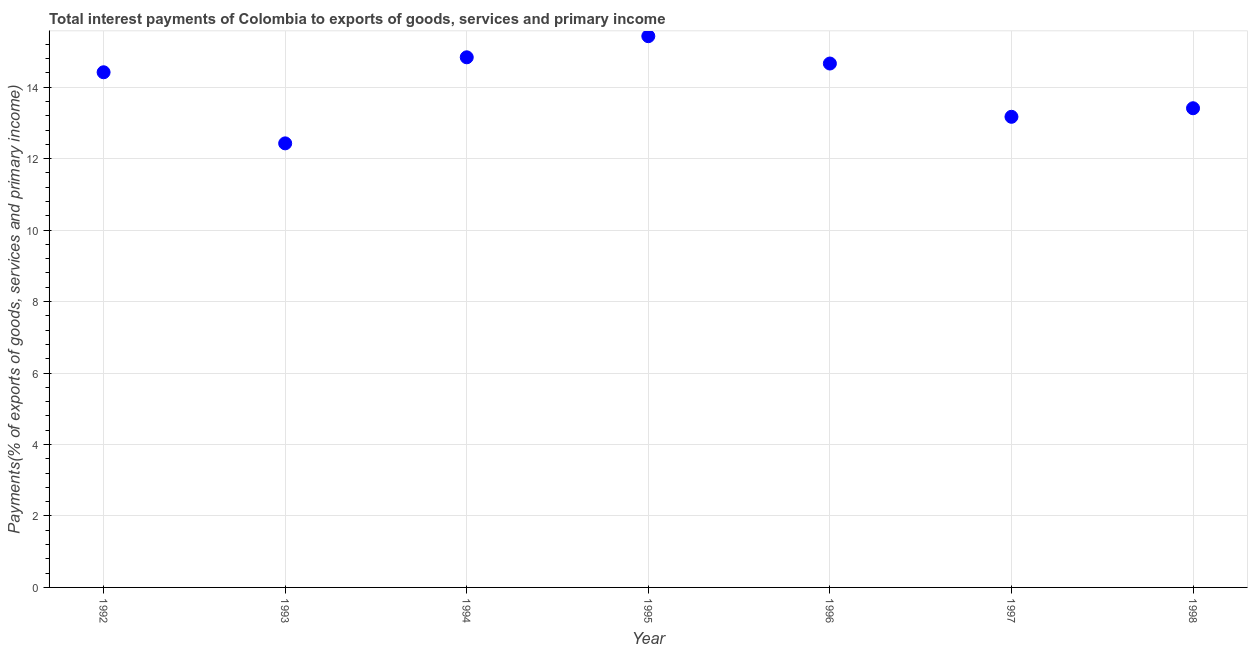What is the total interest payments on external debt in 1992?
Your answer should be very brief. 14.42. Across all years, what is the maximum total interest payments on external debt?
Provide a succinct answer. 15.43. Across all years, what is the minimum total interest payments on external debt?
Keep it short and to the point. 12.43. In which year was the total interest payments on external debt maximum?
Offer a very short reply. 1995. In which year was the total interest payments on external debt minimum?
Your response must be concise. 1993. What is the sum of the total interest payments on external debt?
Your answer should be very brief. 98.34. What is the difference between the total interest payments on external debt in 1996 and 1998?
Keep it short and to the point. 1.25. What is the average total interest payments on external debt per year?
Provide a short and direct response. 14.05. What is the median total interest payments on external debt?
Provide a short and direct response. 14.42. In how many years, is the total interest payments on external debt greater than 11.6 %?
Ensure brevity in your answer.  7. What is the ratio of the total interest payments on external debt in 1993 to that in 1996?
Your response must be concise. 0.85. Is the total interest payments on external debt in 1994 less than that in 1997?
Give a very brief answer. No. What is the difference between the highest and the second highest total interest payments on external debt?
Your answer should be compact. 0.59. What is the difference between the highest and the lowest total interest payments on external debt?
Ensure brevity in your answer.  3. In how many years, is the total interest payments on external debt greater than the average total interest payments on external debt taken over all years?
Your response must be concise. 4. Does the total interest payments on external debt monotonically increase over the years?
Your answer should be very brief. No. How many dotlines are there?
Give a very brief answer. 1. How many years are there in the graph?
Make the answer very short. 7. Does the graph contain any zero values?
Keep it short and to the point. No. What is the title of the graph?
Offer a very short reply. Total interest payments of Colombia to exports of goods, services and primary income. What is the label or title of the X-axis?
Keep it short and to the point. Year. What is the label or title of the Y-axis?
Provide a succinct answer. Payments(% of exports of goods, services and primary income). What is the Payments(% of exports of goods, services and primary income) in 1992?
Make the answer very short. 14.42. What is the Payments(% of exports of goods, services and primary income) in 1993?
Provide a succinct answer. 12.43. What is the Payments(% of exports of goods, services and primary income) in 1994?
Keep it short and to the point. 14.84. What is the Payments(% of exports of goods, services and primary income) in 1995?
Provide a succinct answer. 15.43. What is the Payments(% of exports of goods, services and primary income) in 1996?
Make the answer very short. 14.66. What is the Payments(% of exports of goods, services and primary income) in 1997?
Your response must be concise. 13.17. What is the Payments(% of exports of goods, services and primary income) in 1998?
Keep it short and to the point. 13.41. What is the difference between the Payments(% of exports of goods, services and primary income) in 1992 and 1993?
Your answer should be compact. 1.99. What is the difference between the Payments(% of exports of goods, services and primary income) in 1992 and 1994?
Ensure brevity in your answer.  -0.42. What is the difference between the Payments(% of exports of goods, services and primary income) in 1992 and 1995?
Keep it short and to the point. -1.01. What is the difference between the Payments(% of exports of goods, services and primary income) in 1992 and 1996?
Give a very brief answer. -0.24. What is the difference between the Payments(% of exports of goods, services and primary income) in 1992 and 1997?
Offer a terse response. 1.25. What is the difference between the Payments(% of exports of goods, services and primary income) in 1992 and 1998?
Your response must be concise. 1.01. What is the difference between the Payments(% of exports of goods, services and primary income) in 1993 and 1994?
Make the answer very short. -2.41. What is the difference between the Payments(% of exports of goods, services and primary income) in 1993 and 1995?
Provide a succinct answer. -3. What is the difference between the Payments(% of exports of goods, services and primary income) in 1993 and 1996?
Your response must be concise. -2.23. What is the difference between the Payments(% of exports of goods, services and primary income) in 1993 and 1997?
Your answer should be compact. -0.74. What is the difference between the Payments(% of exports of goods, services and primary income) in 1993 and 1998?
Keep it short and to the point. -0.98. What is the difference between the Payments(% of exports of goods, services and primary income) in 1994 and 1995?
Your answer should be compact. -0.59. What is the difference between the Payments(% of exports of goods, services and primary income) in 1994 and 1996?
Your answer should be very brief. 0.17. What is the difference between the Payments(% of exports of goods, services and primary income) in 1994 and 1997?
Your answer should be very brief. 1.66. What is the difference between the Payments(% of exports of goods, services and primary income) in 1994 and 1998?
Provide a short and direct response. 1.43. What is the difference between the Payments(% of exports of goods, services and primary income) in 1995 and 1996?
Ensure brevity in your answer.  0.77. What is the difference between the Payments(% of exports of goods, services and primary income) in 1995 and 1997?
Give a very brief answer. 2.26. What is the difference between the Payments(% of exports of goods, services and primary income) in 1995 and 1998?
Your answer should be very brief. 2.02. What is the difference between the Payments(% of exports of goods, services and primary income) in 1996 and 1997?
Your answer should be compact. 1.49. What is the difference between the Payments(% of exports of goods, services and primary income) in 1996 and 1998?
Offer a very short reply. 1.25. What is the difference between the Payments(% of exports of goods, services and primary income) in 1997 and 1998?
Keep it short and to the point. -0.24. What is the ratio of the Payments(% of exports of goods, services and primary income) in 1992 to that in 1993?
Offer a terse response. 1.16. What is the ratio of the Payments(% of exports of goods, services and primary income) in 1992 to that in 1994?
Your response must be concise. 0.97. What is the ratio of the Payments(% of exports of goods, services and primary income) in 1992 to that in 1995?
Your response must be concise. 0.94. What is the ratio of the Payments(% of exports of goods, services and primary income) in 1992 to that in 1996?
Make the answer very short. 0.98. What is the ratio of the Payments(% of exports of goods, services and primary income) in 1992 to that in 1997?
Make the answer very short. 1.09. What is the ratio of the Payments(% of exports of goods, services and primary income) in 1992 to that in 1998?
Ensure brevity in your answer.  1.07. What is the ratio of the Payments(% of exports of goods, services and primary income) in 1993 to that in 1994?
Ensure brevity in your answer.  0.84. What is the ratio of the Payments(% of exports of goods, services and primary income) in 1993 to that in 1995?
Offer a terse response. 0.81. What is the ratio of the Payments(% of exports of goods, services and primary income) in 1993 to that in 1996?
Your answer should be very brief. 0.85. What is the ratio of the Payments(% of exports of goods, services and primary income) in 1993 to that in 1997?
Ensure brevity in your answer.  0.94. What is the ratio of the Payments(% of exports of goods, services and primary income) in 1993 to that in 1998?
Your answer should be compact. 0.93. What is the ratio of the Payments(% of exports of goods, services and primary income) in 1994 to that in 1995?
Give a very brief answer. 0.96. What is the ratio of the Payments(% of exports of goods, services and primary income) in 1994 to that in 1997?
Offer a very short reply. 1.13. What is the ratio of the Payments(% of exports of goods, services and primary income) in 1994 to that in 1998?
Provide a short and direct response. 1.11. What is the ratio of the Payments(% of exports of goods, services and primary income) in 1995 to that in 1996?
Ensure brevity in your answer.  1.05. What is the ratio of the Payments(% of exports of goods, services and primary income) in 1995 to that in 1997?
Your answer should be compact. 1.17. What is the ratio of the Payments(% of exports of goods, services and primary income) in 1995 to that in 1998?
Your answer should be compact. 1.15. What is the ratio of the Payments(% of exports of goods, services and primary income) in 1996 to that in 1997?
Provide a short and direct response. 1.11. What is the ratio of the Payments(% of exports of goods, services and primary income) in 1996 to that in 1998?
Provide a short and direct response. 1.09. 